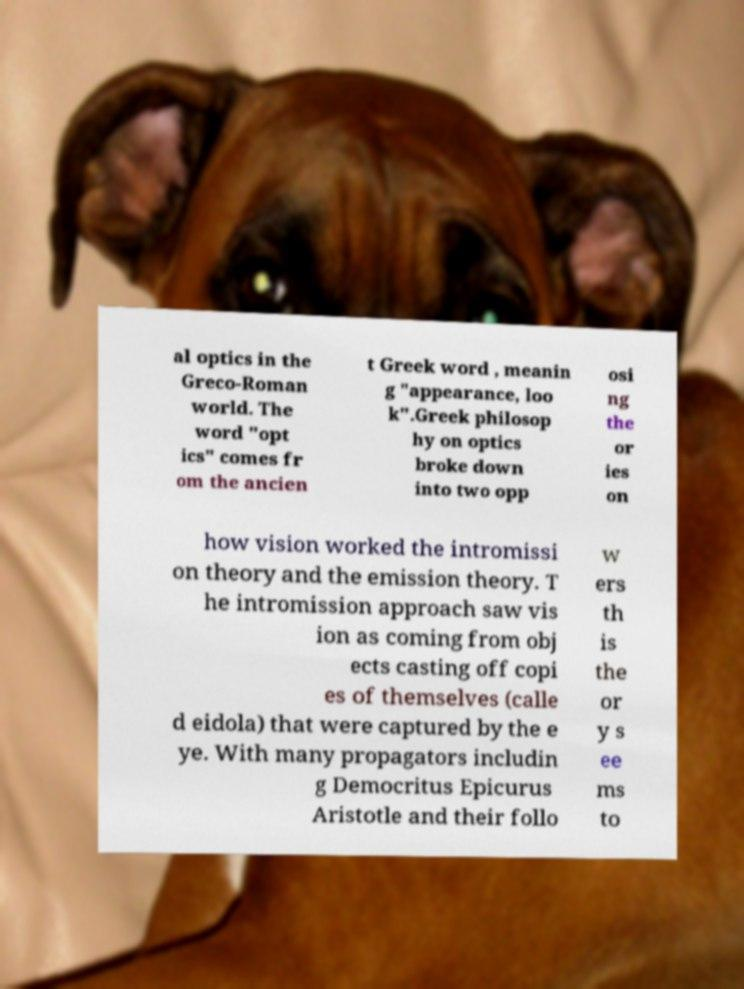Could you extract and type out the text from this image? al optics in the Greco-Roman world. The word "opt ics" comes fr om the ancien t Greek word , meanin g "appearance, loo k".Greek philosop hy on optics broke down into two opp osi ng the or ies on how vision worked the intromissi on theory and the emission theory. T he intromission approach saw vis ion as coming from obj ects casting off copi es of themselves (calle d eidola) that were captured by the e ye. With many propagators includin g Democritus Epicurus Aristotle and their follo w ers th is the or y s ee ms to 